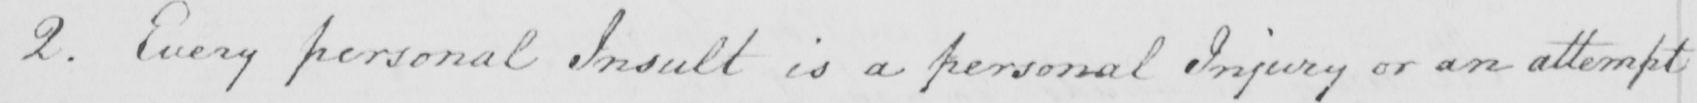Can you tell me what this handwritten text says? 2 . Every personal Insult is a personal Injury or an attempt 